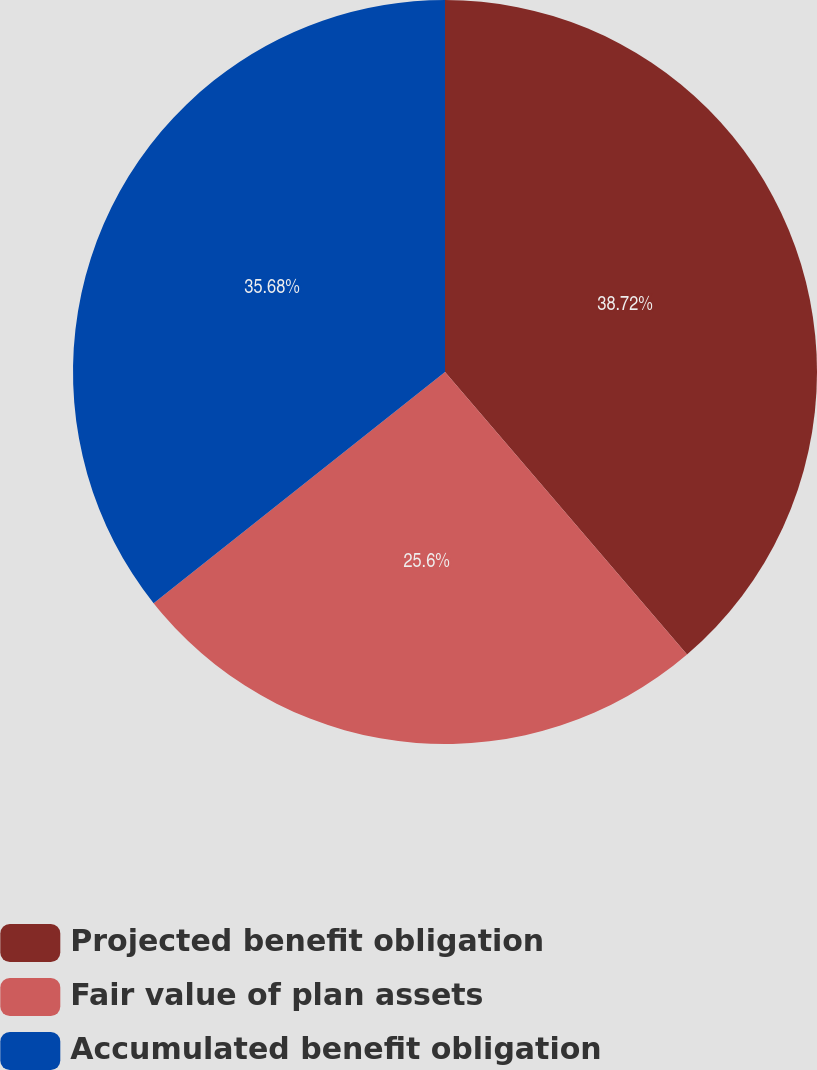Convert chart to OTSL. <chart><loc_0><loc_0><loc_500><loc_500><pie_chart><fcel>Projected benefit obligation<fcel>Fair value of plan assets<fcel>Accumulated benefit obligation<nl><fcel>38.73%<fcel>25.6%<fcel>35.68%<nl></chart> 